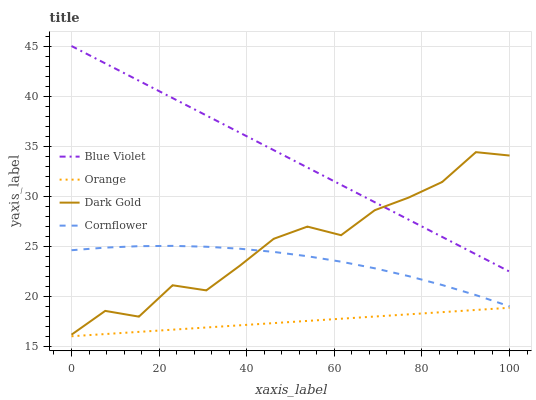Does Cornflower have the minimum area under the curve?
Answer yes or no. No. Does Cornflower have the maximum area under the curve?
Answer yes or no. No. Is Cornflower the smoothest?
Answer yes or no. No. Is Cornflower the roughest?
Answer yes or no. No. Does Cornflower have the lowest value?
Answer yes or no. No. Does Cornflower have the highest value?
Answer yes or no. No. Is Orange less than Cornflower?
Answer yes or no. Yes. Is Blue Violet greater than Cornflower?
Answer yes or no. Yes. Does Orange intersect Cornflower?
Answer yes or no. No. 